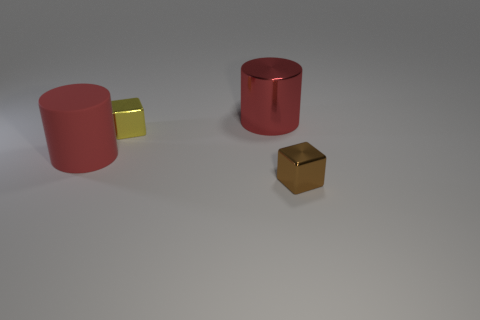Add 2 small brown metallic blocks. How many objects exist? 6 Add 1 large rubber cylinders. How many large rubber cylinders exist? 2 Subtract 0 red spheres. How many objects are left? 4 Subtract all large metallic cylinders. Subtract all yellow shiny cubes. How many objects are left? 2 Add 4 small brown shiny cubes. How many small brown shiny cubes are left? 5 